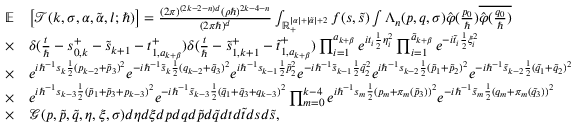Convert formula to latex. <formula><loc_0><loc_0><loc_500><loc_500>\begin{array} { r l } { \mathbb { E } } & { \left [ \mathcal { T } ( k , \sigma , \alpha , \tilde { \alpha } , l ; \hbar { ) } \right ] = \frac { ( 2 \pi ) ^ { ( 2 k - 2 - n ) d } ( \rho \hbar { ) } ^ { 2 k - 4 - n } } { ( 2 \pi \hbar { ) } ^ { d } } \int _ { \mathbb { R } _ { + } ^ { | \alpha | + | \tilde { \alpha } | + 2 } } f ( s , \tilde { s } ) \int \Lambda _ { n } ( p , q , \sigma ) \hat { \varphi } ( \frac { p _ { 0 } } { } ) \overline { { \hat { \varphi } ( \frac { q _ { 0 } } { } ) } } } \\ { \times } & { \delta ( \frac { t } { } - s _ { 0 , k } ^ { + } - \tilde { s } _ { k + 1 } - t _ { 1 , a _ { k + \beta } } ^ { + } ) \delta ( \frac { t } { } - \tilde { s } _ { 1 , k + 1 } ^ { + } - \tilde { t } _ { 1 , a _ { k + \beta } } ^ { + } ) \prod _ { i = 1 } ^ { a _ { k + \beta } } e ^ { i t _ { i } \frac { 1 } { 2 } \eta _ { i } ^ { 2 } } \prod _ { i = 1 } ^ { \tilde { a } _ { k + \beta } } e ^ { - i \tilde { t } _ { i } \frac { 1 } { 2 } \xi _ { i } ^ { 2 } } } \\ { \times } & { e ^ { i \hbar { ^ } { - 1 } s _ { k } \frac { 1 } { 2 } ( p _ { k - 2 } + \tilde { p } _ { 3 } ) ^ { 2 } } e ^ { - i \hbar { ^ } { - 1 } \tilde { s } _ { k } \frac { 1 } { 2 } ( q _ { k - 2 } + \tilde { q } _ { 3 } ) ^ { 2 } } e ^ { i \hbar { ^ } { - 1 } s _ { k - 1 } \frac { 1 } { 2 } \tilde { p } _ { 2 } ^ { 2 } } e ^ { - i \hbar { ^ } { - 1 } \tilde { s } _ { k - 1 } \frac { 1 } { 2 } \tilde { q } _ { 2 } ^ { 2 } } e ^ { i \hbar { ^ } { - 1 } s _ { k - 2 } \frac { 1 } { 2 } ( \tilde { p } _ { 1 } + \tilde { p } _ { 2 } ) ^ { 2 } } e ^ { - i \hbar { ^ } { - 1 } \tilde { s } _ { k - 2 } \frac { 1 } { 2 } ( \tilde { q } _ { 1 } + \tilde { q } _ { 2 } ) ^ { 2 } } } \\ { \times } & { e ^ { i \hbar { ^ } { - 1 } s _ { k - 3 } \frac { 1 } { 2 } ( \tilde { p } _ { 1 } + \tilde { p } _ { 3 } + p _ { k - 3 } ) ^ { 2 } } e ^ { - i \hbar { ^ } { - 1 } \tilde { s } _ { k - 3 } \frac { 1 } { 2 } ( \tilde { q } _ { 1 } + \tilde { q } _ { 3 } + q _ { k - 3 } ) ^ { 2 } } \prod _ { m = 0 } ^ { k - 4 } e ^ { i \hbar { ^ } { - 1 } s _ { m } \frac { 1 } { 2 } ( p _ { m } + \pi _ { m } ( \tilde { p } _ { 3 } ) ) ^ { 2 } } e ^ { - i \hbar { ^ } { - 1 } \tilde { s } _ { m } \frac { 1 } { 2 } ( q _ { m } + \pi _ { m } ( \tilde { q } _ { 3 } ) ) ^ { 2 } } } \\ { \times } & { \mathcal { G } ( p , \tilde { p } , \tilde { q } , \eta , \xi , \sigma ) d \eta d \xi d p d q d \tilde { p } d \tilde { q } d t d \tilde { t } d s d \tilde { s } , } \end{array}</formula> 